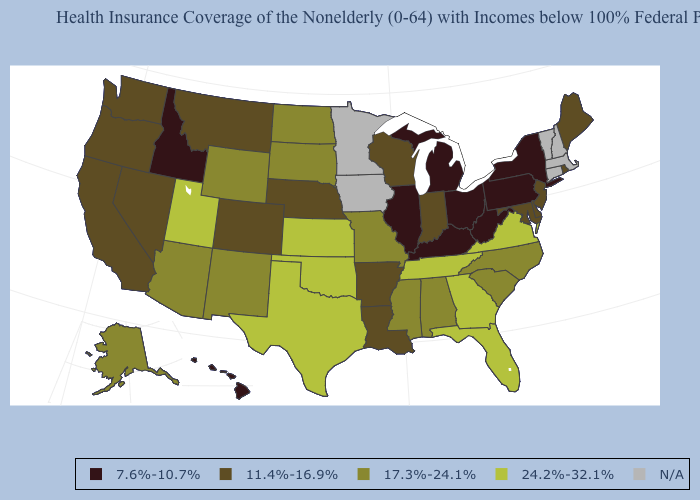Name the states that have a value in the range 7.6%-10.7%?
Short answer required. Hawaii, Idaho, Illinois, Kentucky, Michigan, New York, Ohio, Pennsylvania, West Virginia. What is the highest value in the West ?
Quick response, please. 24.2%-32.1%. Among the states that border Michigan , does Ohio have the highest value?
Concise answer only. No. What is the lowest value in states that border New Mexico?
Answer briefly. 11.4%-16.9%. Name the states that have a value in the range N/A?
Answer briefly. Connecticut, Iowa, Massachusetts, Minnesota, New Hampshire, Vermont. Is the legend a continuous bar?
Give a very brief answer. No. How many symbols are there in the legend?
Short answer required. 5. What is the lowest value in states that border Utah?
Write a very short answer. 7.6%-10.7%. Name the states that have a value in the range 17.3%-24.1%?
Write a very short answer. Alabama, Alaska, Arizona, Mississippi, Missouri, New Mexico, North Carolina, North Dakota, South Carolina, South Dakota, Wyoming. Name the states that have a value in the range 11.4%-16.9%?
Short answer required. Arkansas, California, Colorado, Delaware, Indiana, Louisiana, Maine, Maryland, Montana, Nebraska, Nevada, New Jersey, Oregon, Rhode Island, Washington, Wisconsin. Which states have the lowest value in the Northeast?
Quick response, please. New York, Pennsylvania. What is the highest value in the West ?
Write a very short answer. 24.2%-32.1%. 